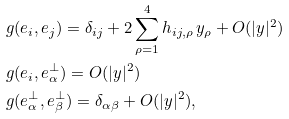Convert formula to latex. <formula><loc_0><loc_0><loc_500><loc_500>& g ( e _ { i } , e _ { j } ) = \delta _ { i j } + 2 \sum _ { \rho = 1 } ^ { 4 } h _ { i j , \rho } \, y _ { \rho } + O ( | y | ^ { 2 } ) \\ & g ( e _ { i } , e _ { \alpha } ^ { \perp } ) = O ( | y | ^ { 2 } ) \\ & g ( e _ { \alpha } ^ { \perp } , e _ { \beta } ^ { \perp } ) = \delta _ { \alpha \beta } + O ( | y | ^ { 2 } ) ,</formula> 